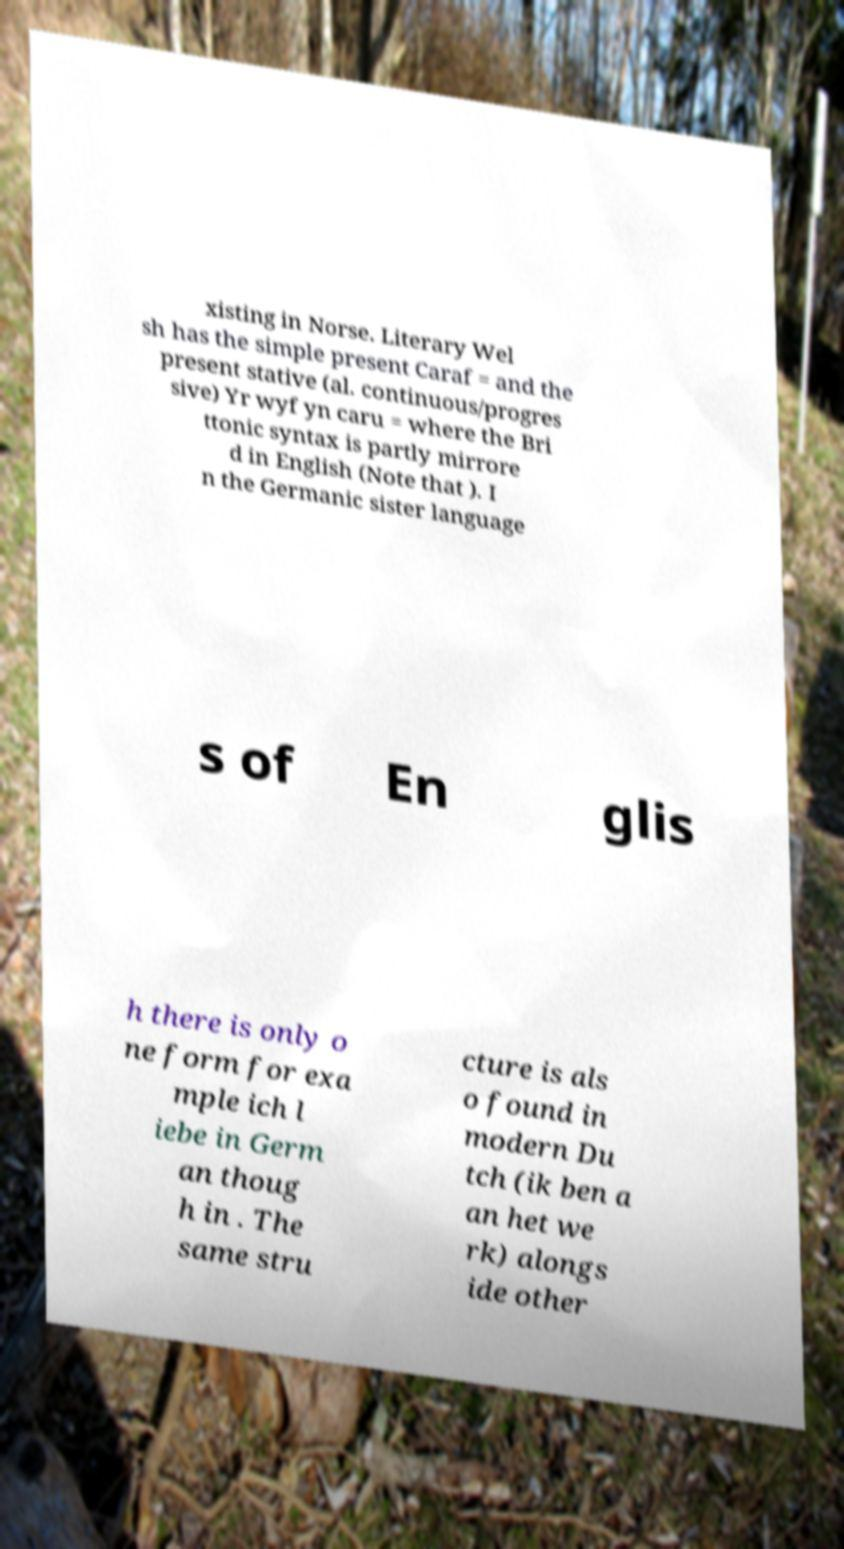Please identify and transcribe the text found in this image. xisting in Norse. Literary Wel sh has the simple present Caraf = and the present stative (al. continuous/progres sive) Yr wyf yn caru = where the Bri ttonic syntax is partly mirrore d in English (Note that ). I n the Germanic sister language s of En glis h there is only o ne form for exa mple ich l iebe in Germ an thoug h in . The same stru cture is als o found in modern Du tch (ik ben a an het we rk) alongs ide other 